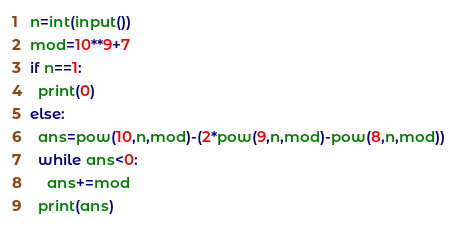Convert code to text. <code><loc_0><loc_0><loc_500><loc_500><_Python_>n=int(input())
mod=10**9+7
if n==1:
  print(0)
else:
  ans=pow(10,n,mod)-(2*pow(9,n,mod)-pow(8,n,mod))
  while ans<0:
    ans+=mod
  print(ans)</code> 